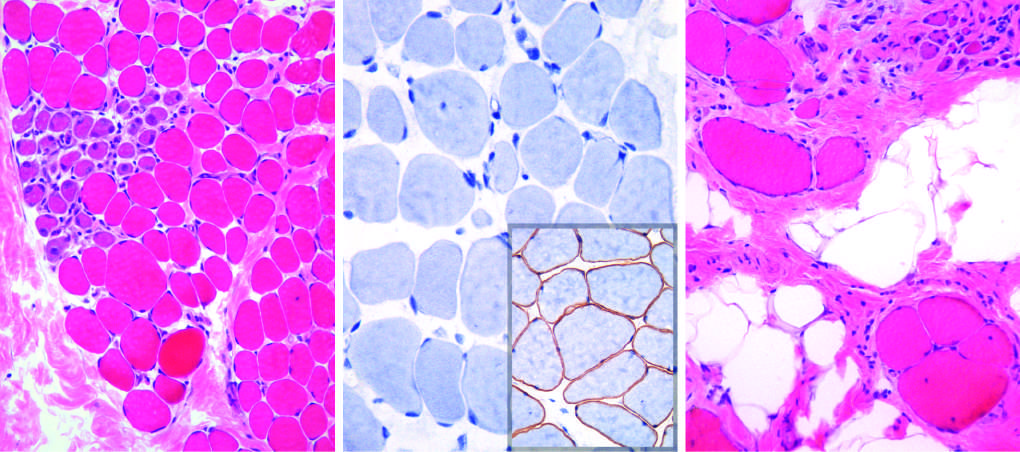what show variation in size?
Answer the question using a single word or phrase. Myofibers 